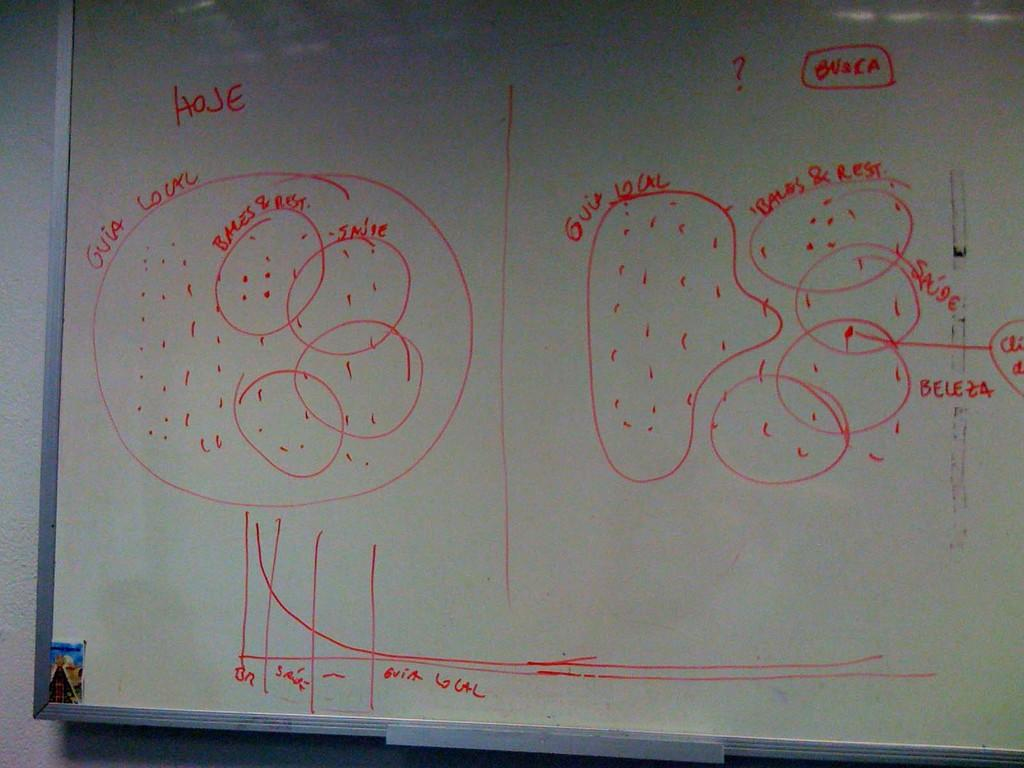<image>
Give a short and clear explanation of the subsequent image. a drawing on a blackboard describing Gvia Lourc 